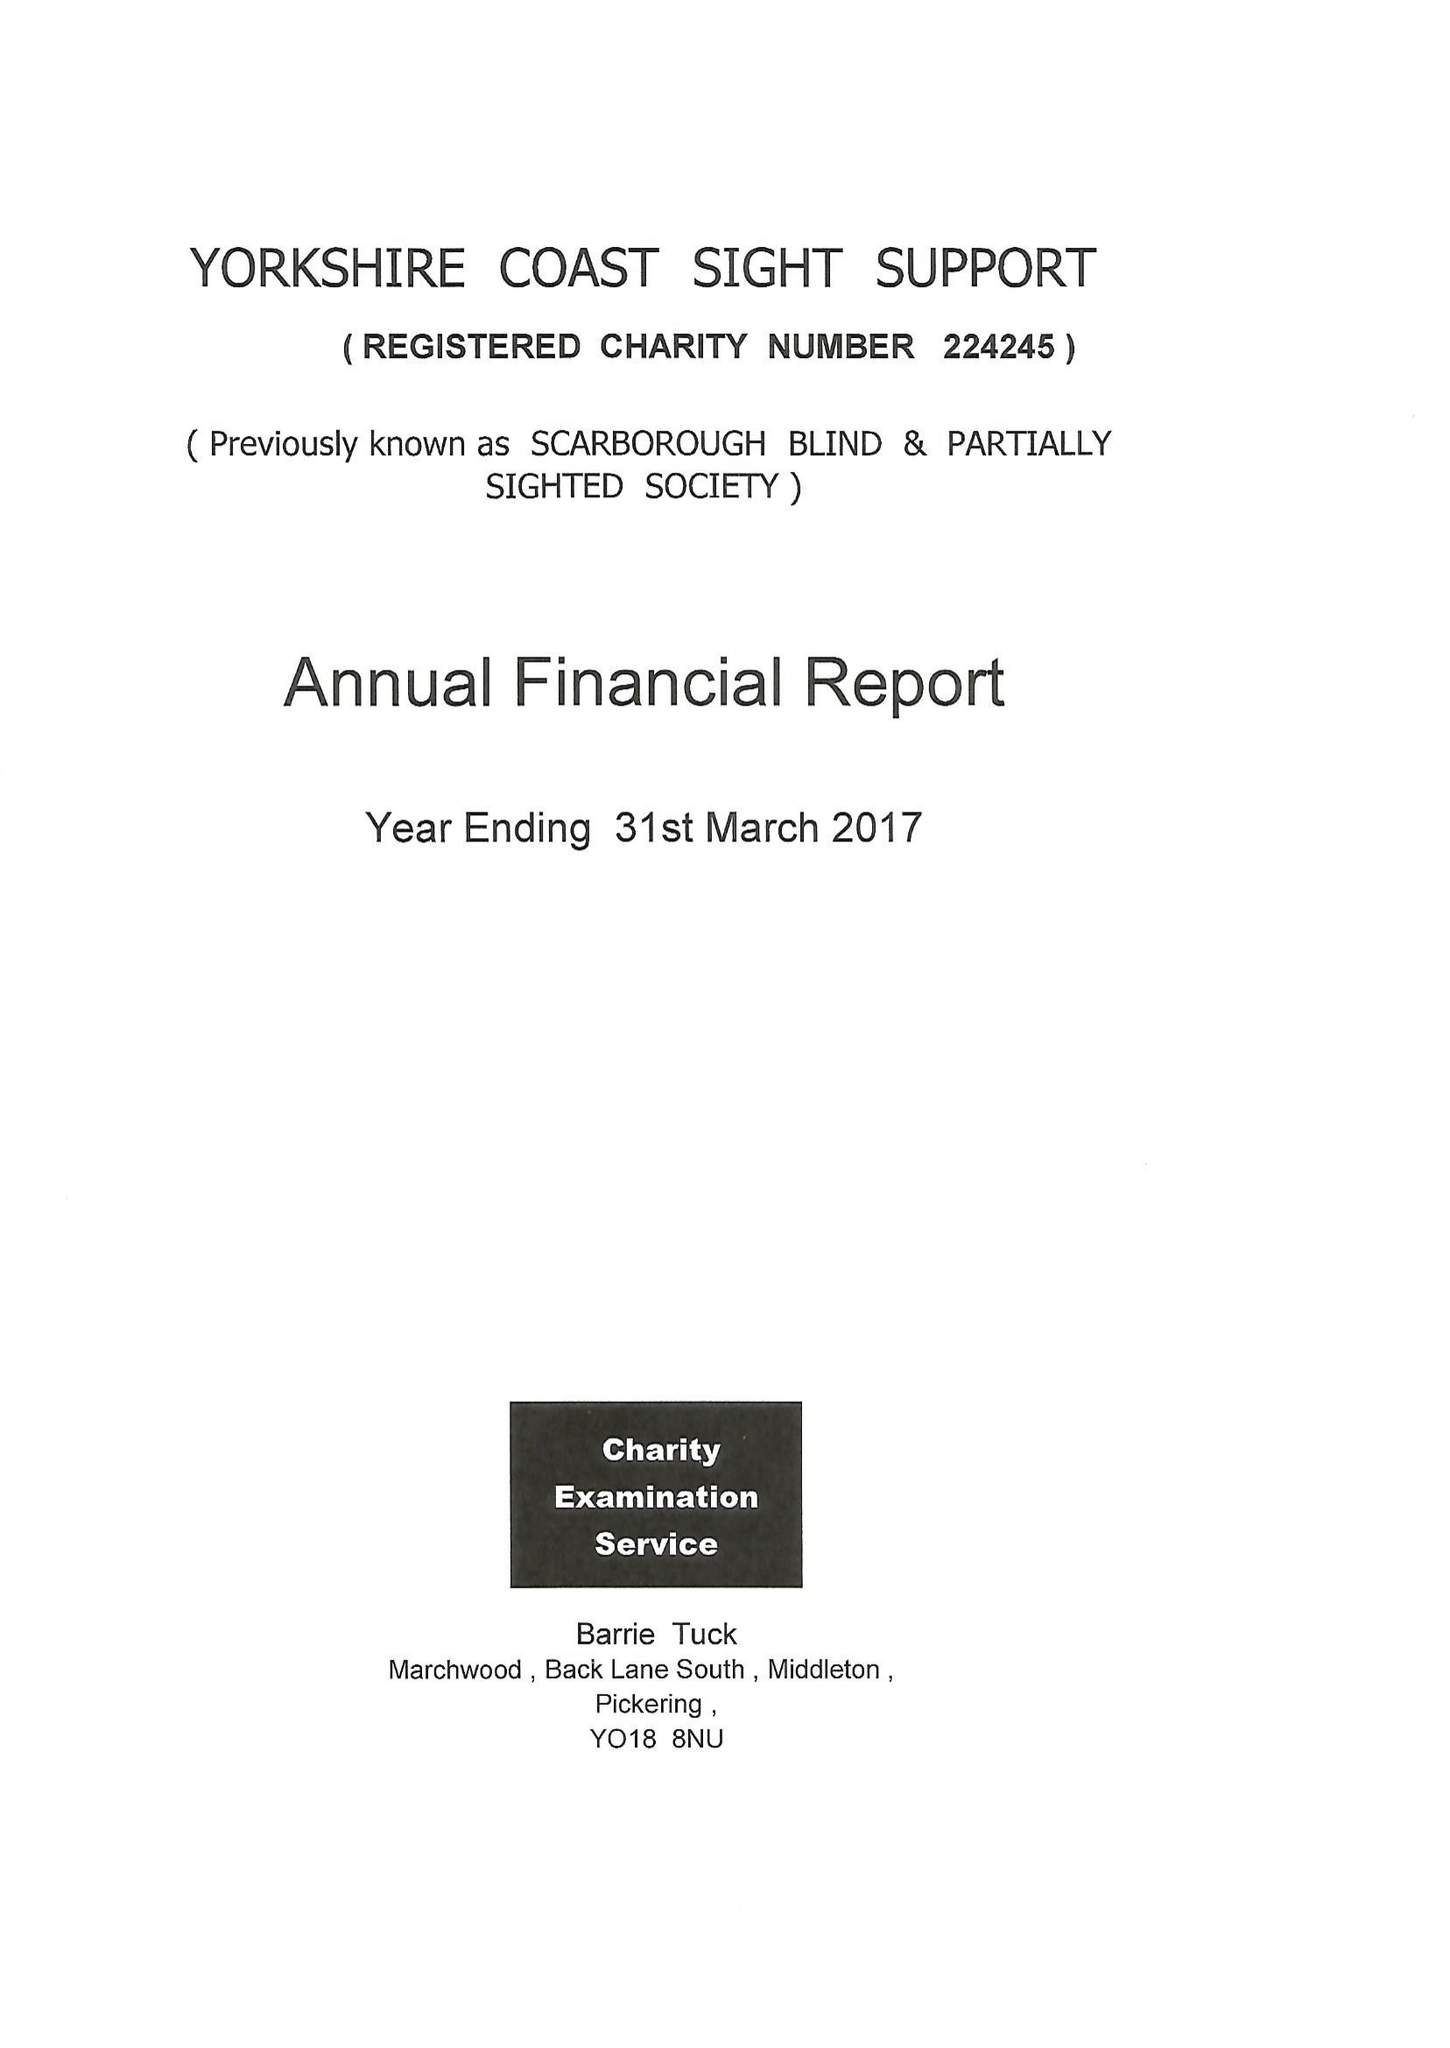What is the value for the charity_name?
Answer the question using a single word or phrase. Yorkshire Coast Sight Support 